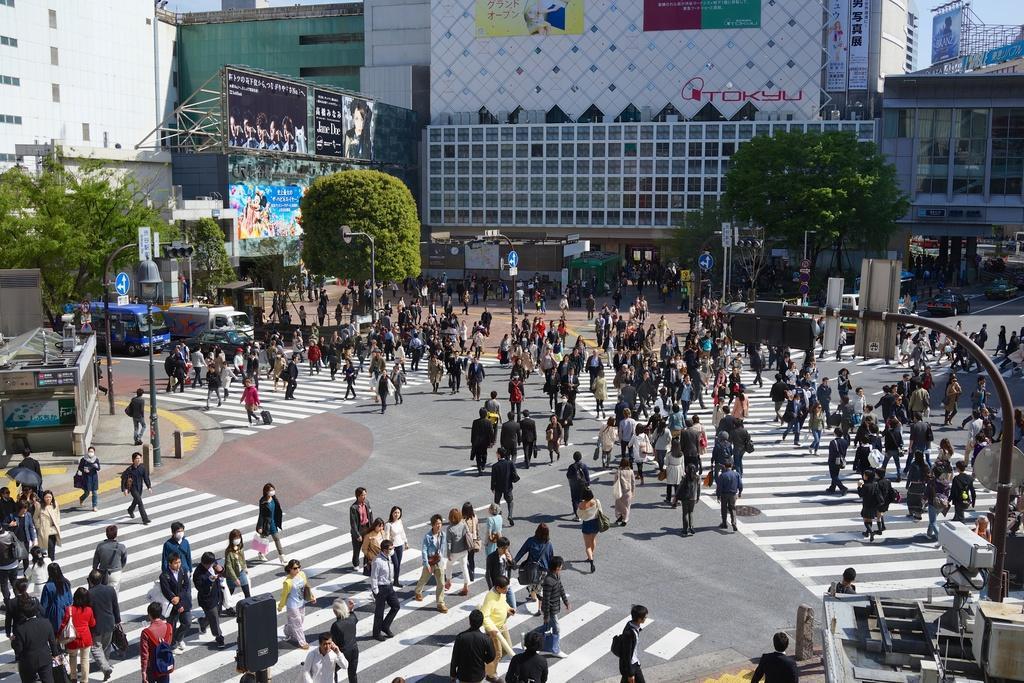In one or two sentences, can you explain what this image depicts? In this picture we can see some people are walking and some are standing on the road. On the left and right side of the people there are poles with lights and sign boards. Behind the people there are vehicles, trees, hoardings, buildings and the sky. 